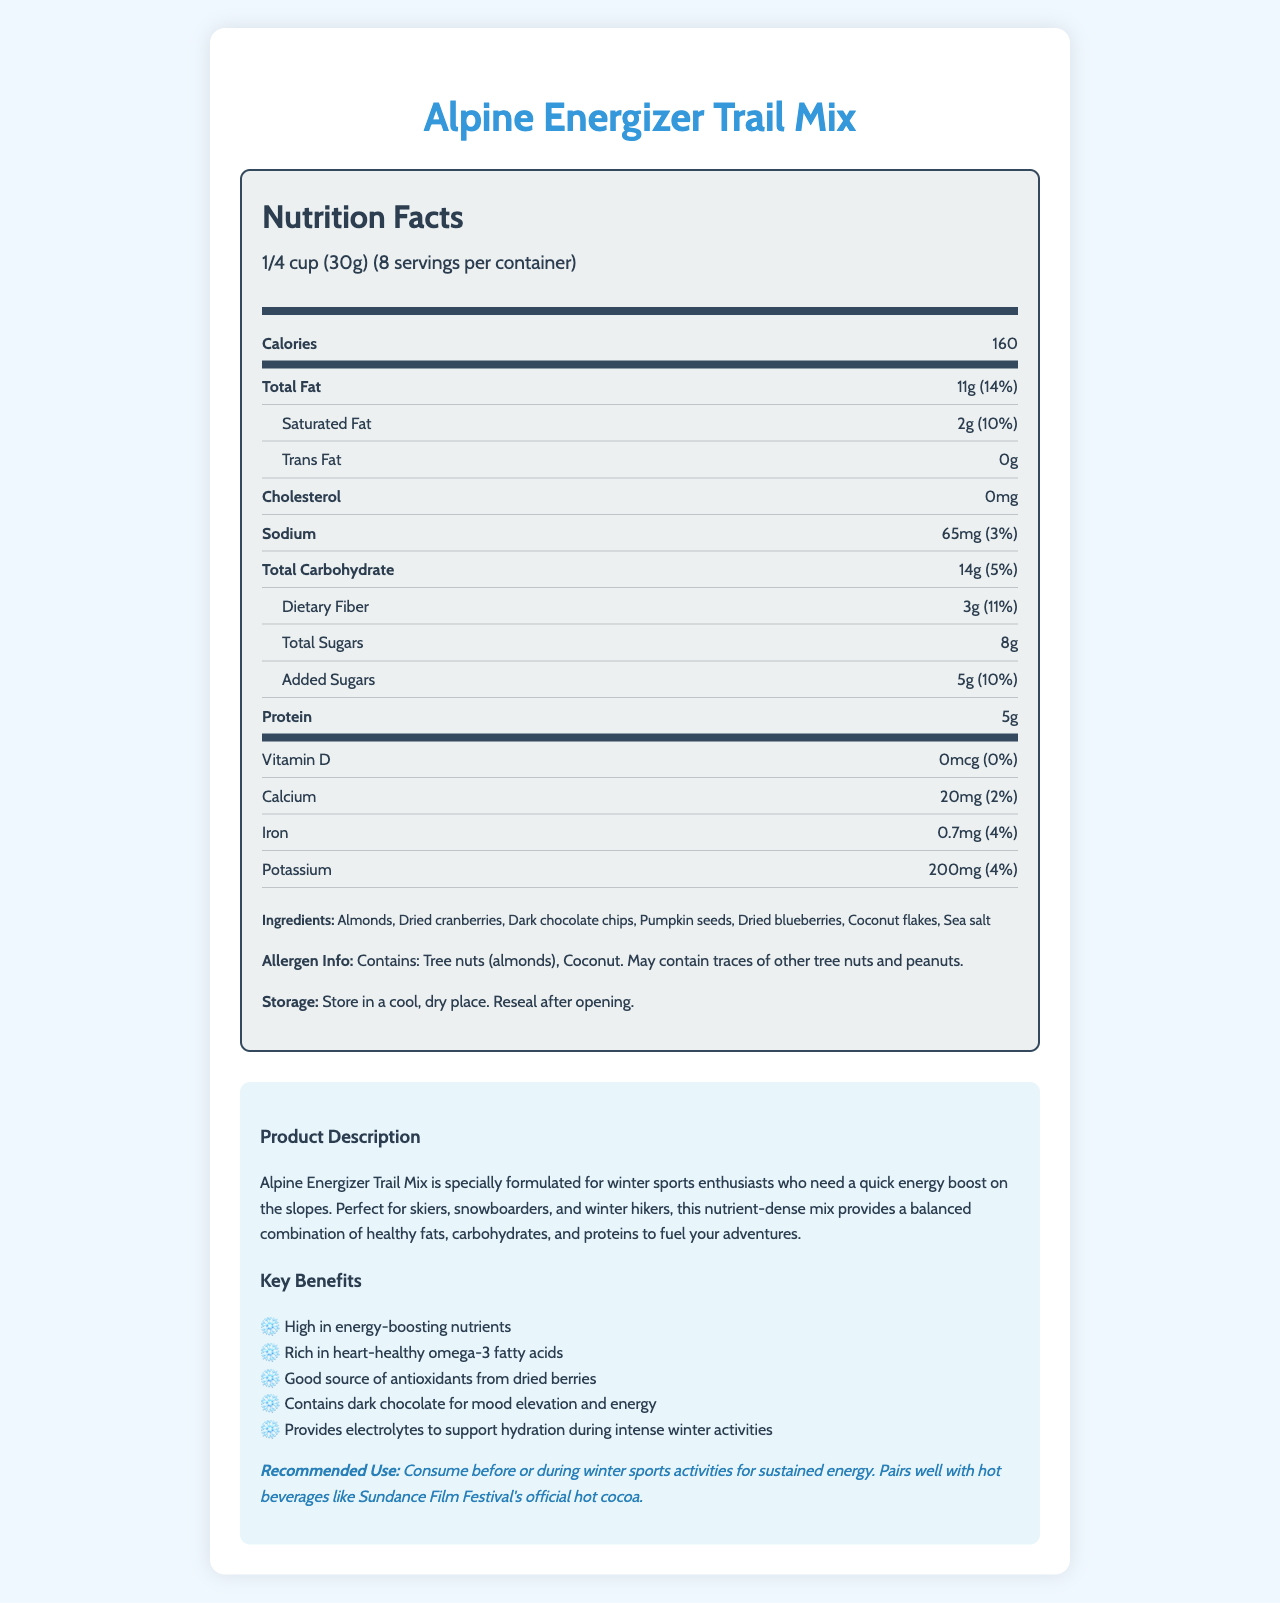what is the product name? The product name is prominently displayed at the top of the document.
Answer: Alpine Energizer Trail Mix how many servings are there per container? Under the serving information, it states that there are 8 servings per container.
Answer: 8 how many calories are there per serving? The calorie count per serving is stated directly in the nutrition facts section.
Answer: 160 calories what is the amount of total fat per serving? The nutrition facts section lists the amount of total fat as 11g per serving.
Answer: 11g which ingredient is not listed in the trail mix? A. Almonds B. Cashews C. Dark chocolate chips The ingredient list includes Almonds and Dark chocolate chips, but not Cashews.
Answer: B what percentage of the daily value of dietary fiber does one serving provide? The document lists dietary fiber as 3g, with an 11% daily value.
Answer: 11% does the trail mix contain any added sugars? The nutrition facts specify that there are 5g of added sugars per serving.
Answer: Yes is there any cholesterol in the Alpine Energizer Trail Mix? The nutrition facts indicate 0mg of cholesterol.
Answer: No what should you do after opening the package? The storage instructions recommend resealing the package after opening.
Answer: Reseal after opening. what benefit does dark chocolate provide according to the document? The benefits list states dark chocolate is included for "mood elevation and energy."
Answer: Mood elevation and energy what is the recommended use of this trail mix? This is mentioned in the product information section under recommended use.
Answer: Consume before or during winter sports activities for sustained energy. Pairs well with hot beverages like Sundance Film Festival's official hot cocoa. does the trail mix contain any allergens? The allergen information states it contains tree nuts (almonds and coconut) and may contain traces of other tree nuts and peanuts.
Answer: Yes what is the main idea of this document? The document provides a comprehensive overview of the trail mix's nutritional content, beneficial ingredients, intended users, and suggested consumption times.
Answer: Description of the Alpine Energizer Trail Mix including its nutrition facts, ingredients, benefits, and recommended use for winter sports enthusiasts. how many grams of protein are in one serving? The nutrition facts section lists protein at 5g per serving.
Answer: 5g which nutrient does not have any daily value percentage listed? A. Vitamin D B. Calcium C. Iron D. Potassium The document shows 0% daily value for Vitamin D, whereas Calcium, Iron, and Potassium have respective percentages.
Answer: A can this trail mix help with hydration? The benefits section mentions that it provides electrolytes to support hydration during intense winter activities.
Answer: Yes what is the total amount of carbohydrates in one serving? The nutrition facts list the total carbohydrate content as 14g per serving.
Answer: 14g how should the trail mix be stored? The storage instructions advise storing the trail mix in a cool, dry place and resealing it after opening.
Answer: Store in a cool, dry place. Reseal after opening. what is the percentage of daily value of sodium in one serving? The document lists the sodium content as 65mg with a 3% daily value.
Answer: 3% who is this product mainly designed for? The product description specifies that the trail mix is formulated for winter sports enthusiasts needing a quick energy boost.
Answer: Winter sports enthusiasts how much calcium is there per serving and what is its daily value percentage? The nutrition facts indicate that each serving provides 20mg of calcium, which is 2% of the daily value.
Answer: 20mg, 2% what are the possible tree nuts and peanuts traces other than almonds and coconut in this trail mix? The allergen information mentions it may contain traces of other tree nuts and peanuts, but does not specify which ones.
Answer: Cannot be determined 